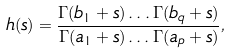Convert formula to latex. <formula><loc_0><loc_0><loc_500><loc_500>h ( s ) = \frac { \Gamma ( b _ { 1 } + s ) \dots \Gamma ( b _ { q } + s ) } { \Gamma ( a _ { 1 } + s ) \dots \Gamma ( a _ { p } + s ) } ,</formula> 